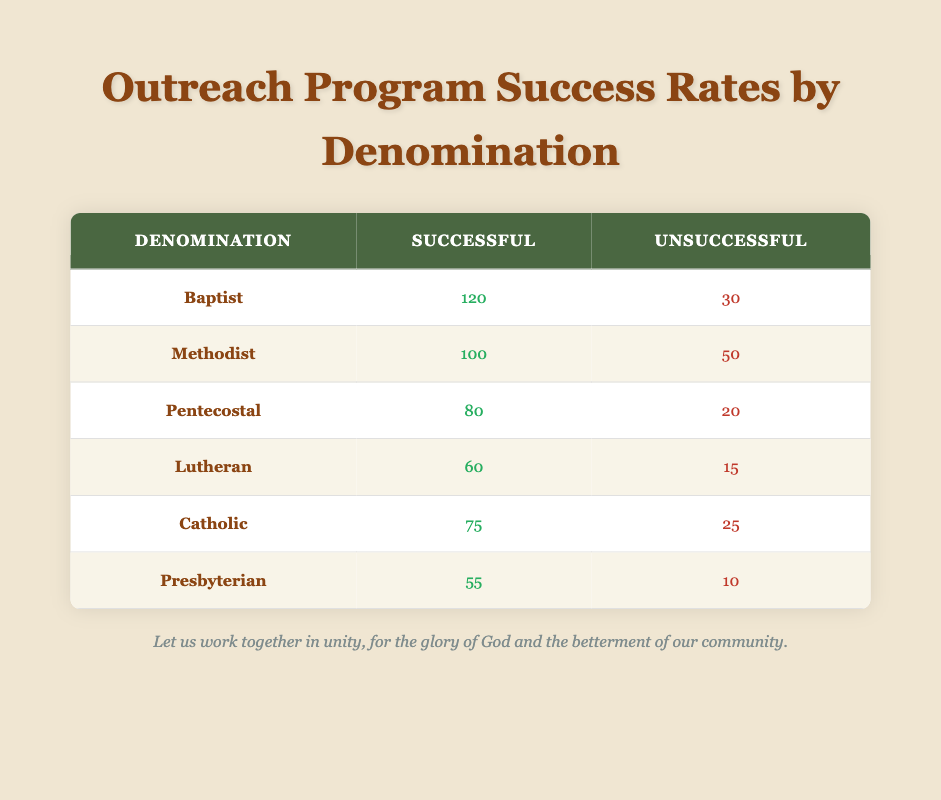What denomination had the highest number of successful outreach programs? By examining the "Successful" column, the highest value is 120, which corresponds to the Baptist denomination.
Answer: Baptist What is the total number of unsuccessful outreach programs across all denominations? To find the total, we sum the "Unsuccessful" column: 30 (Baptist) + 50 (Methodist) + 20 (Pentecostal) + 15 (Lutheran) + 25 (Catholic) + 10 (Presbyterian) = 150.
Answer: 150 Which denomination had the lowest success rate based on the percentage of successful programs? The success rate is calculated as (Successful / (Successful + Unsuccessful)) * 100. For each denomination: 
- Baptist: (120 / 150) * 100 = 80%
- Methodist: (100 / 150) * 100 = 66.67%
- Pentecostal: (80 / 100) * 100 = 80%
- Lutheran: (60 / 75) * 100 = 80%
- Catholic: (75 / 100) * 100 = 75%
- Presbyterian: (55 / 65) * 100 = 84.62%
The lowest is for the Catholic denomination at 75%.
Answer: Catholic Did the Lutheran denomination have more successful or unsuccessful outreach programs? The Lutheran denomination has 60 successful and 15 unsuccessful outreach programs, indicating that successful programs are greater in number.
Answer: Yes What is the average number of successful outreach programs across all denominations? To calculate the average, we first sum the "Successful" values: 120 + 100 + 80 + 60 + 75 + 55 = 490. Then, we divide by the number of denominations, which is 6: 490 / 6 = approximately 81.67.
Answer: 81.67 